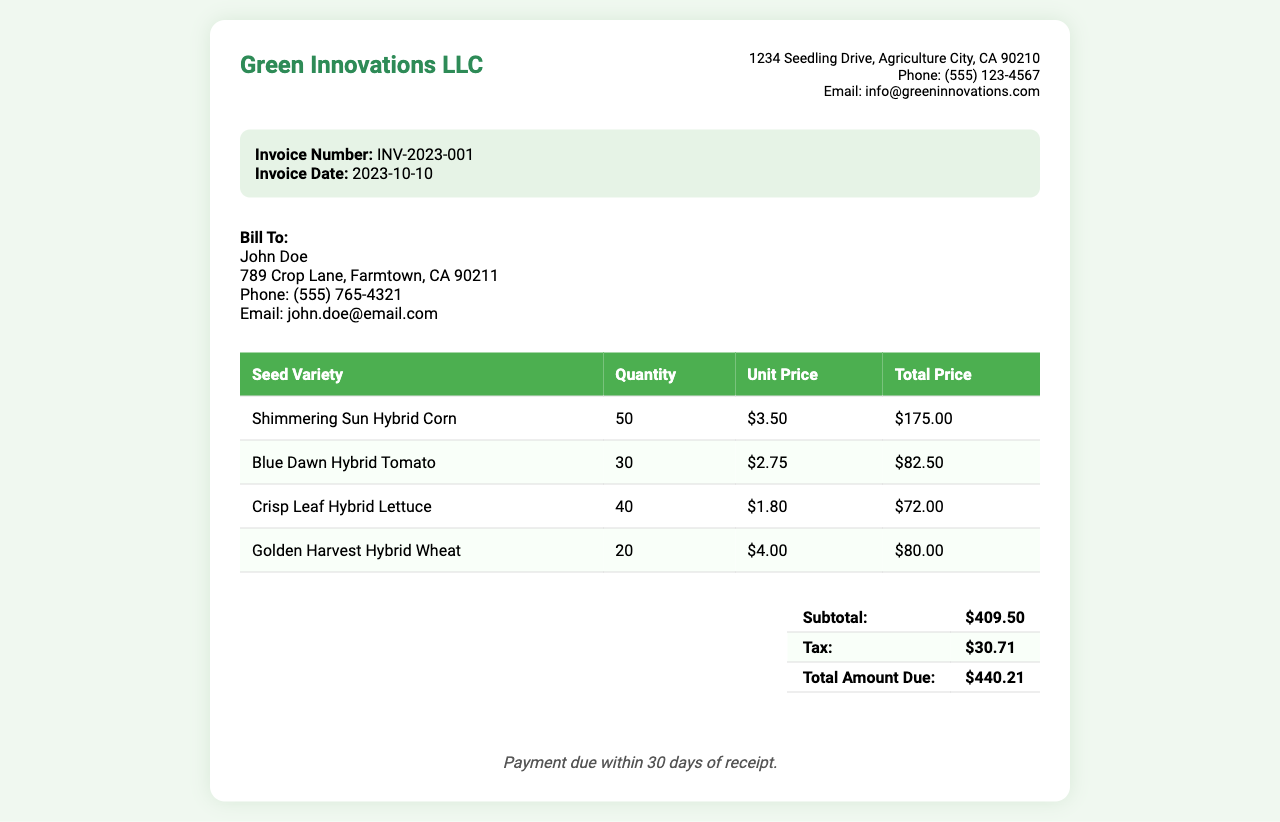What is the invoice number? The invoice number is identifiable information specific to this transaction, found in the invoice details section.
Answer: INV-2023-001 Who is the client? The client's name is recorded in the client information section of the invoice.
Answer: John Doe What is the total amount due? The total amount due is calculated and presented in the summary of costs on the invoice.
Answer: $440.21 How many units of Crisp Leaf Hybrid Lettuce were purchased? The quantity of Crisp Leaf Hybrid Lettuce is listed in the table detailing the seed varieties.
Answer: 40 What is the unit price of Blue Dawn Hybrid Tomato? The unit price can be found in the seed variety pricing table adjacent to Blue Dawn Hybrid Tomato.
Answer: $2.75 What is the subtotal before tax? The subtotal is the total price of all seed varieties before tax, found in the total section of the invoice.
Answer: $409.50 What is the tax amount? The tax amount is specified in the total section of the invoice, detailing additional fees.
Answer: $30.71 What is the payment term specified in the invoice? The payment term indicates the time frame within which the payment must be completed, noted in the payment terms section.
Answer: Payment due within 30 days of receipt 